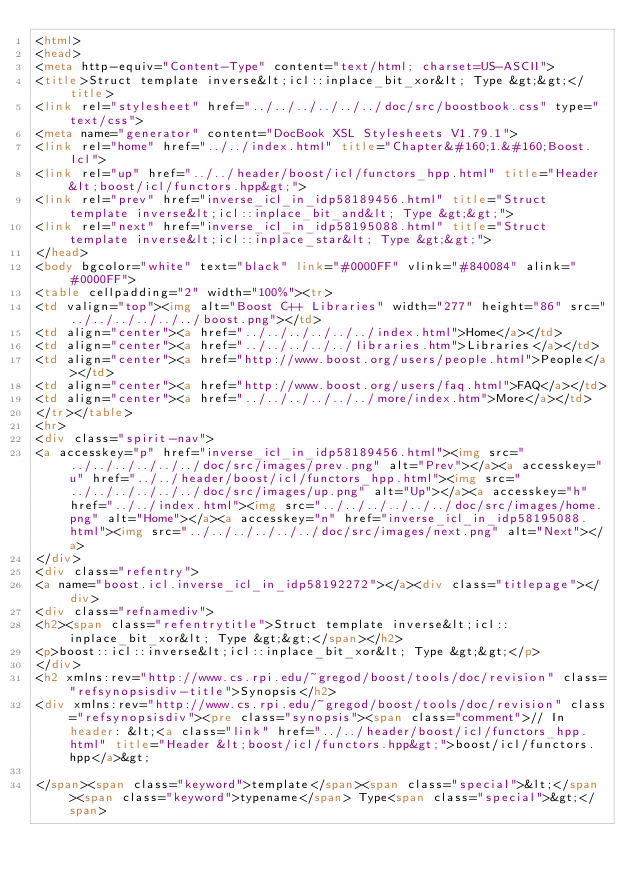Convert code to text. <code><loc_0><loc_0><loc_500><loc_500><_HTML_><html>
<head>
<meta http-equiv="Content-Type" content="text/html; charset=US-ASCII">
<title>Struct template inverse&lt;icl::inplace_bit_xor&lt; Type &gt;&gt;</title>
<link rel="stylesheet" href="../../../../../../doc/src/boostbook.css" type="text/css">
<meta name="generator" content="DocBook XSL Stylesheets V1.79.1">
<link rel="home" href="../../index.html" title="Chapter&#160;1.&#160;Boost.Icl">
<link rel="up" href="../../header/boost/icl/functors_hpp.html" title="Header &lt;boost/icl/functors.hpp&gt;">
<link rel="prev" href="inverse_icl_in_idp58189456.html" title="Struct template inverse&lt;icl::inplace_bit_and&lt; Type &gt;&gt;">
<link rel="next" href="inverse_icl_in_idp58195088.html" title="Struct template inverse&lt;icl::inplace_star&lt; Type &gt;&gt;">
</head>
<body bgcolor="white" text="black" link="#0000FF" vlink="#840084" alink="#0000FF">
<table cellpadding="2" width="100%"><tr>
<td valign="top"><img alt="Boost C++ Libraries" width="277" height="86" src="../../../../../../boost.png"></td>
<td align="center"><a href="../../../../../../index.html">Home</a></td>
<td align="center"><a href="../../../../../libraries.htm">Libraries</a></td>
<td align="center"><a href="http://www.boost.org/users/people.html">People</a></td>
<td align="center"><a href="http://www.boost.org/users/faq.html">FAQ</a></td>
<td align="center"><a href="../../../../../../more/index.htm">More</a></td>
</tr></table>
<hr>
<div class="spirit-nav">
<a accesskey="p" href="inverse_icl_in_idp58189456.html"><img src="../../../../../../doc/src/images/prev.png" alt="Prev"></a><a accesskey="u" href="../../header/boost/icl/functors_hpp.html"><img src="../../../../../../doc/src/images/up.png" alt="Up"></a><a accesskey="h" href="../../index.html"><img src="../../../../../../doc/src/images/home.png" alt="Home"></a><a accesskey="n" href="inverse_icl_in_idp58195088.html"><img src="../../../../../../doc/src/images/next.png" alt="Next"></a>
</div>
<div class="refentry">
<a name="boost.icl.inverse_icl_in_idp58192272"></a><div class="titlepage"></div>
<div class="refnamediv">
<h2><span class="refentrytitle">Struct template inverse&lt;icl::inplace_bit_xor&lt; Type &gt;&gt;</span></h2>
<p>boost::icl::inverse&lt;icl::inplace_bit_xor&lt; Type &gt;&gt;</p>
</div>
<h2 xmlns:rev="http://www.cs.rpi.edu/~gregod/boost/tools/doc/revision" class="refsynopsisdiv-title">Synopsis</h2>
<div xmlns:rev="http://www.cs.rpi.edu/~gregod/boost/tools/doc/revision" class="refsynopsisdiv"><pre class="synopsis"><span class="comment">// In header: &lt;<a class="link" href="../../header/boost/icl/functors_hpp.html" title="Header &lt;boost/icl/functors.hpp&gt;">boost/icl/functors.hpp</a>&gt;

</span><span class="keyword">template</span><span class="special">&lt;</span><span class="keyword">typename</span> Type<span class="special">&gt;</span> </code> 